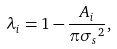<formula> <loc_0><loc_0><loc_500><loc_500>\lambda _ { i } = 1 - \frac { A _ { i } } { \pi { \sigma _ { s } } ^ { 2 } } ,</formula> 